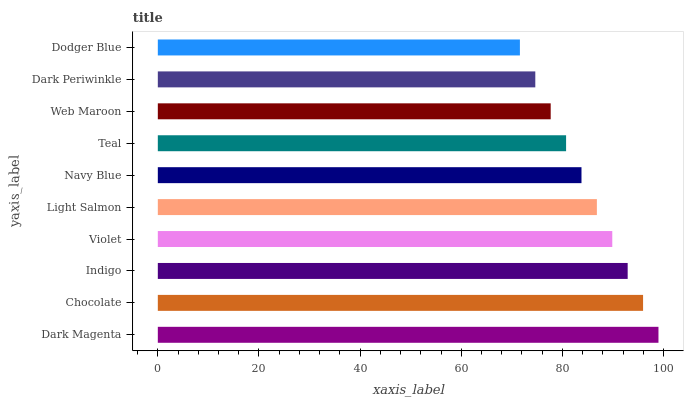Is Dodger Blue the minimum?
Answer yes or no. Yes. Is Dark Magenta the maximum?
Answer yes or no. Yes. Is Chocolate the minimum?
Answer yes or no. No. Is Chocolate the maximum?
Answer yes or no. No. Is Dark Magenta greater than Chocolate?
Answer yes or no. Yes. Is Chocolate less than Dark Magenta?
Answer yes or no. Yes. Is Chocolate greater than Dark Magenta?
Answer yes or no. No. Is Dark Magenta less than Chocolate?
Answer yes or no. No. Is Light Salmon the high median?
Answer yes or no. Yes. Is Navy Blue the low median?
Answer yes or no. Yes. Is Chocolate the high median?
Answer yes or no. No. Is Dark Magenta the low median?
Answer yes or no. No. 